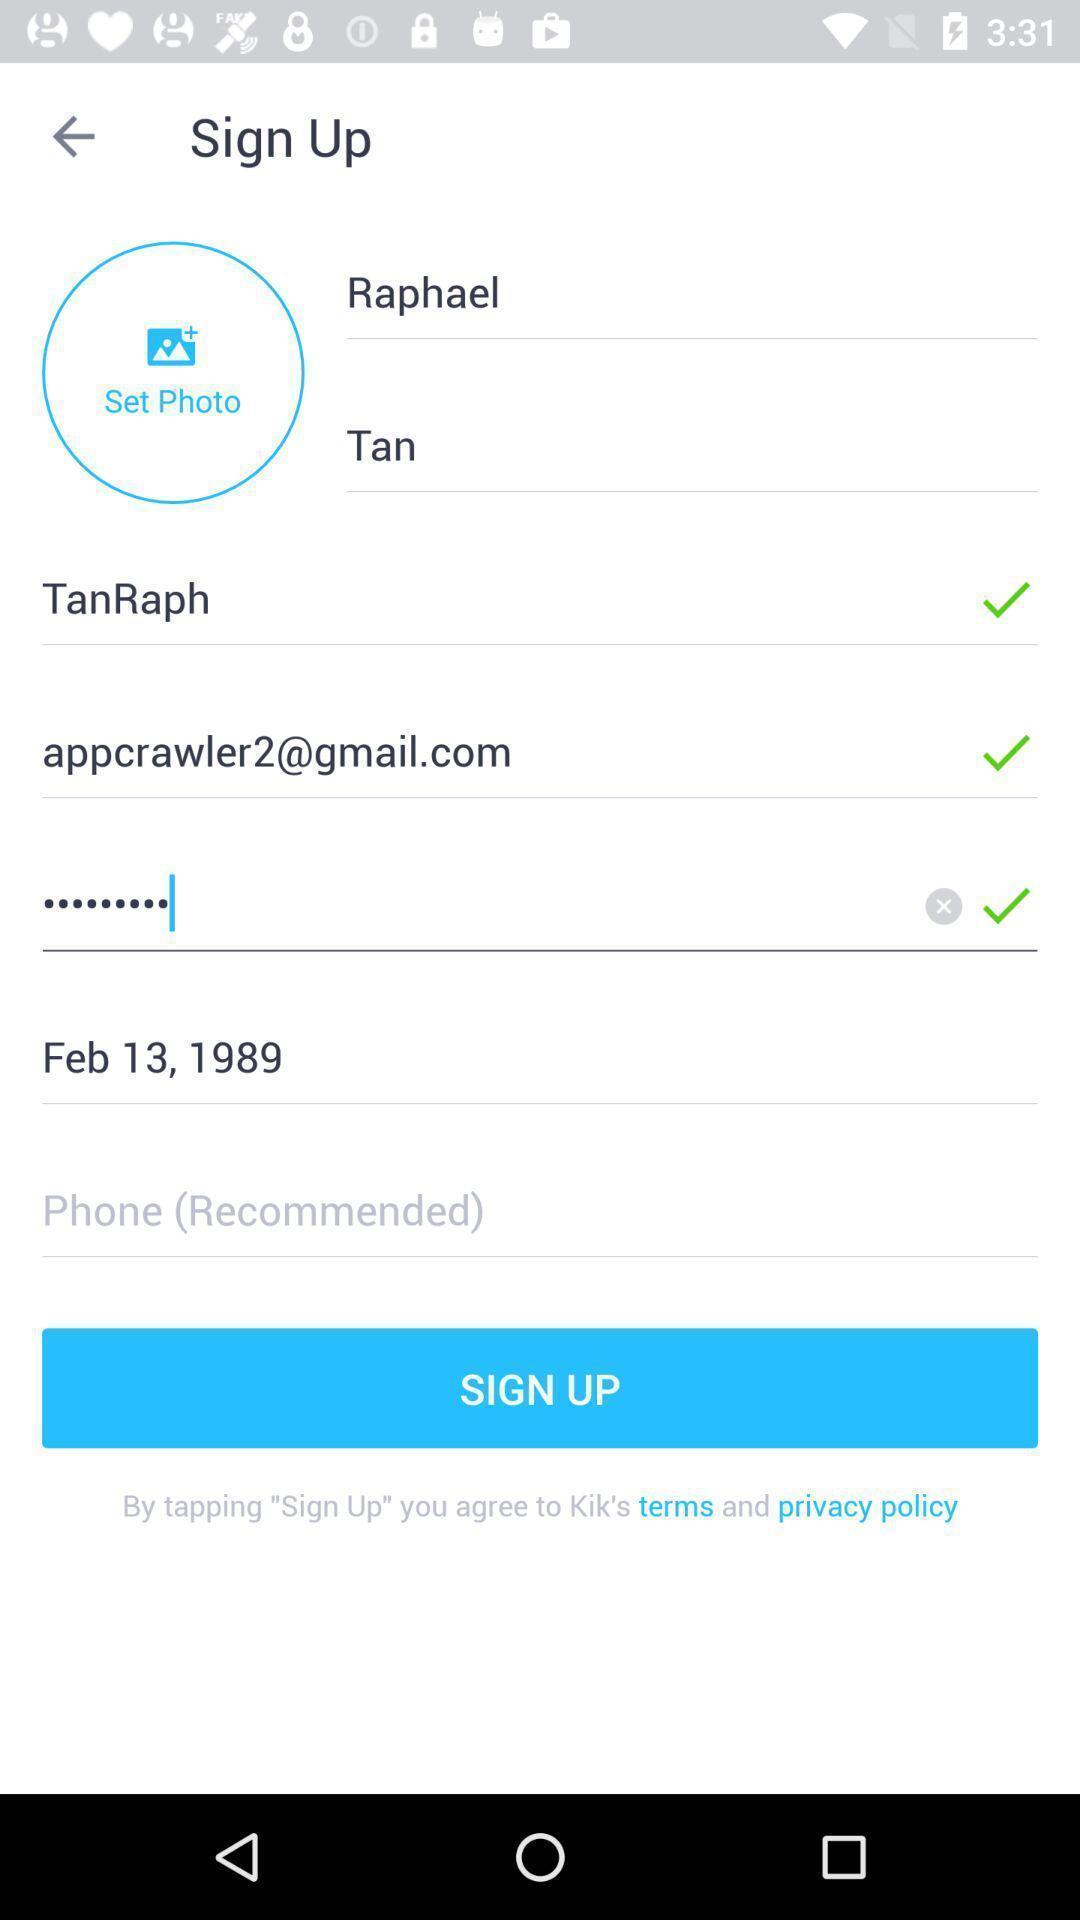Tell me what you see in this picture. Sign up page of the profile. 